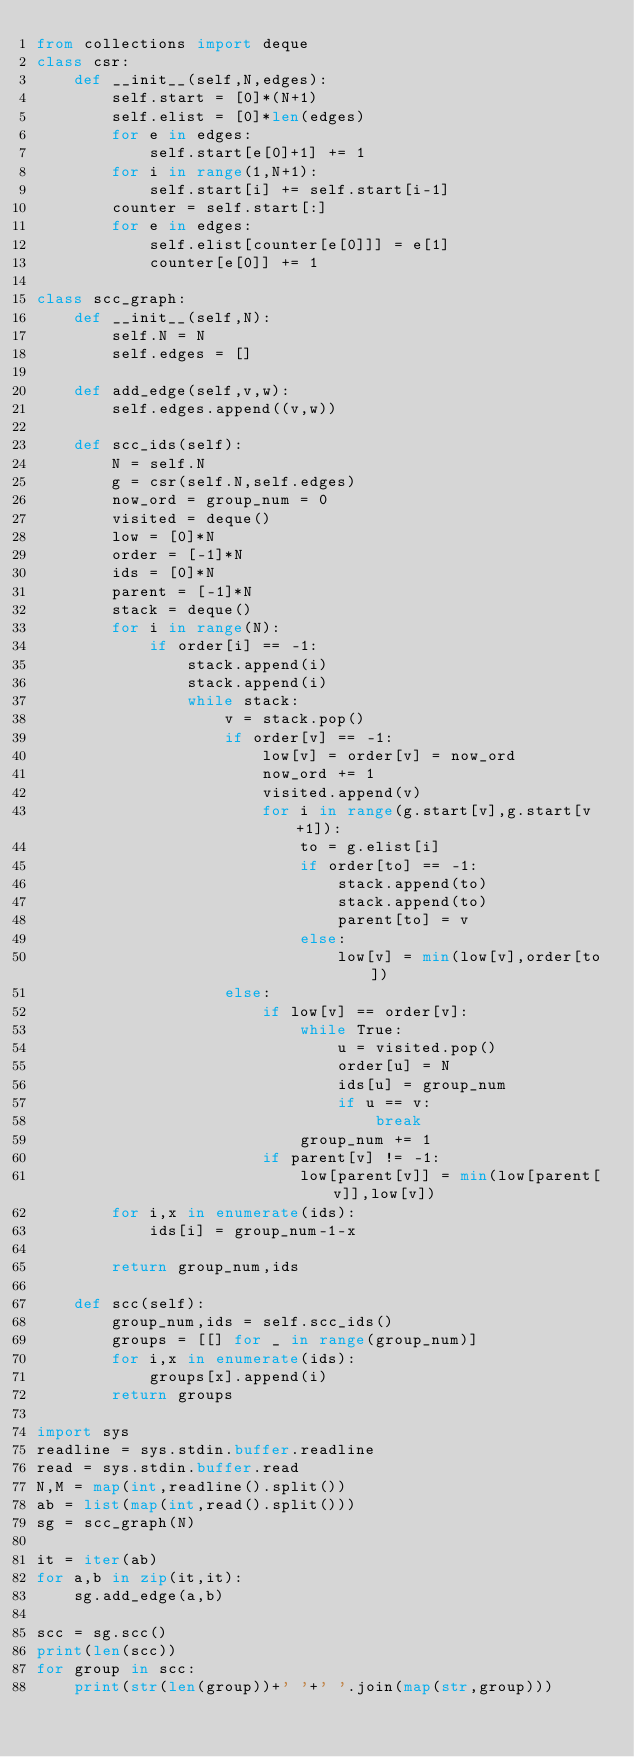<code> <loc_0><loc_0><loc_500><loc_500><_Python_>from collections import deque
class csr:
    def __init__(self,N,edges):
        self.start = [0]*(N+1)
        self.elist = [0]*len(edges)
        for e in edges:
            self.start[e[0]+1] += 1
        for i in range(1,N+1):
            self.start[i] += self.start[i-1] 
        counter = self.start[:]
        for e in edges:
            self.elist[counter[e[0]]] = e[1]
            counter[e[0]] += 1

class scc_graph:
    def __init__(self,N):
        self.N = N
        self.edges = []
    
    def add_edge(self,v,w):
        self.edges.append((v,w))

    def scc_ids(self):
        N = self.N
        g = csr(self.N,self.edges)
        now_ord = group_num = 0
        visited = deque()
        low = [0]*N
        order = [-1]*N
        ids = [0]*N
        parent = [-1]*N
        stack = deque()
        for i in range(N):
            if order[i] == -1:
                stack.append(i)
                stack.append(i)
                while stack:
                    v = stack.pop()
                    if order[v] == -1:
                        low[v] = order[v] = now_ord
                        now_ord += 1
                        visited.append(v)
                        for i in range(g.start[v],g.start[v+1]):
                            to = g.elist[i]
                            if order[to] == -1:
                                stack.append(to)
                                stack.append(to)
                                parent[to] = v
                            else:
                                low[v] = min(low[v],order[to])
                    else:
                        if low[v] == order[v]:
                            while True:
                                u = visited.pop()
                                order[u] = N
                                ids[u] = group_num
                                if u == v:
                                    break
                            group_num += 1
                        if parent[v] != -1:
                            low[parent[v]] = min(low[parent[v]],low[v])
        for i,x in enumerate(ids):
            ids[i] = group_num-1-x

        return group_num,ids
    
    def scc(self):
        group_num,ids = self.scc_ids()
        groups = [[] for _ in range(group_num)]
        for i,x in enumerate(ids):
            groups[x].append(i)
        return groups
    
import sys
readline = sys.stdin.buffer.readline
read = sys.stdin.buffer.read
N,M = map(int,readline().split())
ab = list(map(int,read().split()))
sg = scc_graph(N)

it = iter(ab)
for a,b in zip(it,it):
    sg.add_edge(a,b)

scc = sg.scc()
print(len(scc))
for group in scc:
    print(str(len(group))+' '+' '.join(map(str,group)))
</code> 